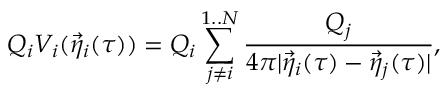<formula> <loc_0><loc_0><loc_500><loc_500>Q _ { i } V _ { i } ( { \vec { \eta } } _ { i } ( \tau ) ) = Q _ { i } \sum _ { j \not = i } ^ { 1 . . N } { \frac { { Q _ { j } } } { { 4 \pi | { \vec { \eta } } _ { i } ( \tau ) - { \vec { \eta } } _ { j } ( \tau ) | } } } ,</formula> 